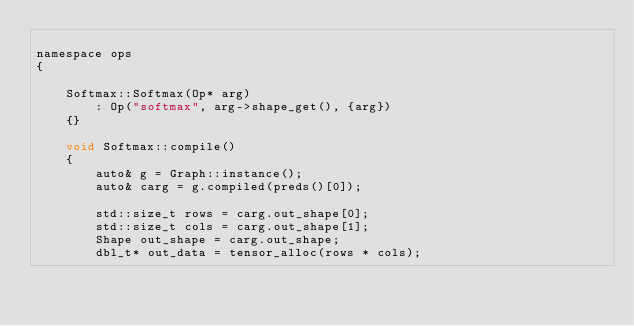Convert code to text. <code><loc_0><loc_0><loc_500><loc_500><_Cuda_>
namespace ops
{

    Softmax::Softmax(Op* arg)
        : Op("softmax", arg->shape_get(), {arg})
    {}

    void Softmax::compile()
    {
        auto& g = Graph::instance();
        auto& carg = g.compiled(preds()[0]);

        std::size_t rows = carg.out_shape[0];
        std::size_t cols = carg.out_shape[1];
        Shape out_shape = carg.out_shape;
        dbl_t* out_data = tensor_alloc(rows * cols);
</code> 